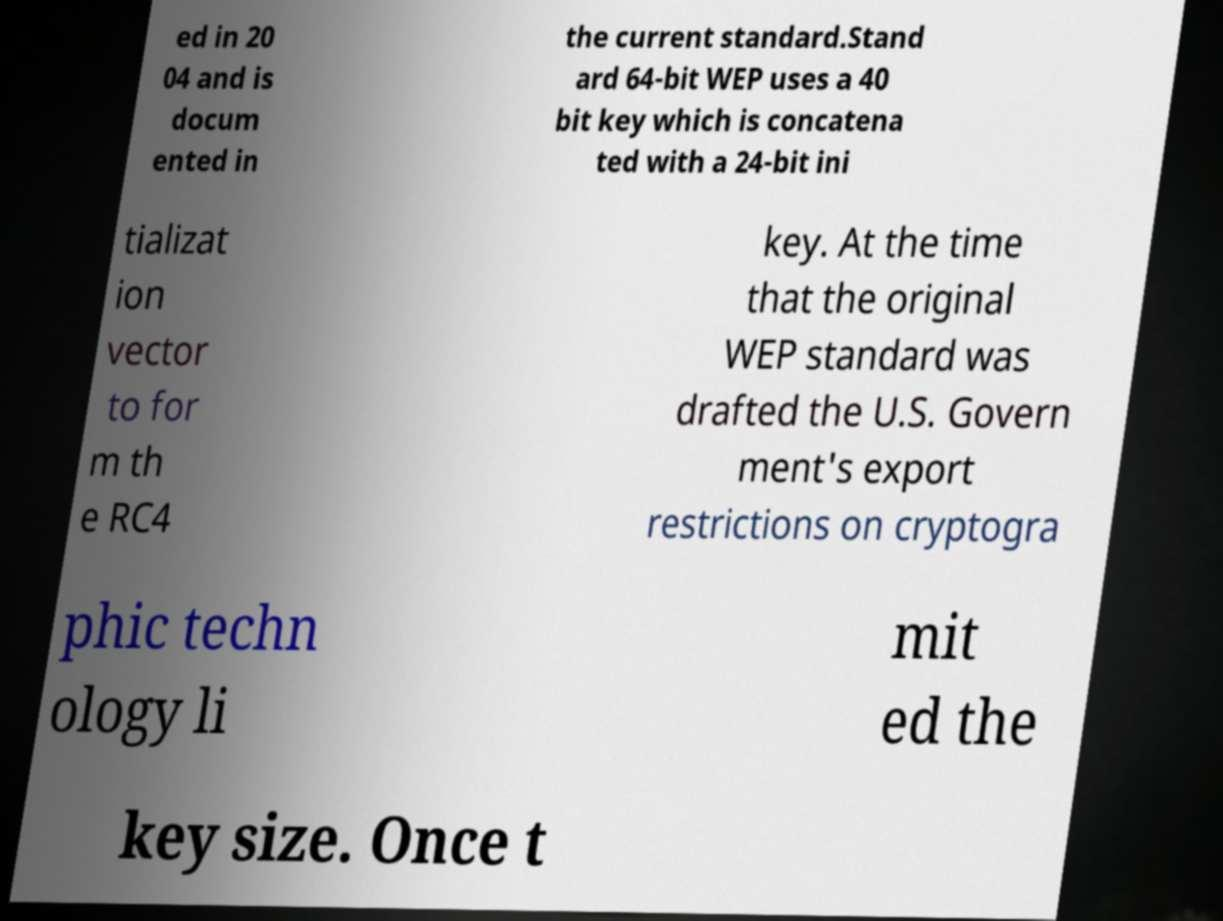What messages or text are displayed in this image? I need them in a readable, typed format. ed in 20 04 and is docum ented in the current standard.Stand ard 64-bit WEP uses a 40 bit key which is concatena ted with a 24-bit ini tializat ion vector to for m th e RC4 key. At the time that the original WEP standard was drafted the U.S. Govern ment's export restrictions on cryptogra phic techn ology li mit ed the key size. Once t 